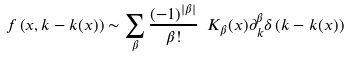<formula> <loc_0><loc_0><loc_500><loc_500>f \left ( x , k - k ( x ) \right ) \sim \sum _ { \beta } \frac { ( - 1 ) ^ { | \beta | } } { \beta ! } \ K _ { \beta } ( x ) \partial ^ { \beta } _ { k } \delta \left ( k - k ( x ) \right )</formula> 